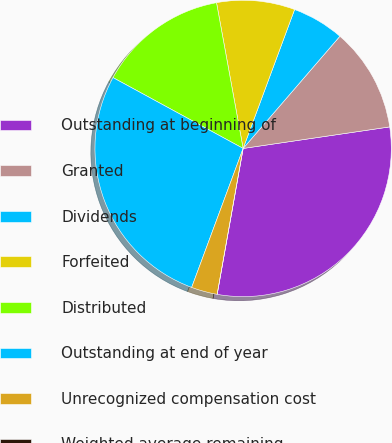Convert chart to OTSL. <chart><loc_0><loc_0><loc_500><loc_500><pie_chart><fcel>Outstanding at beginning of<fcel>Granted<fcel>Dividends<fcel>Forfeited<fcel>Distributed<fcel>Outstanding at end of year<fcel>Unrecognized compensation cost<fcel>Weighted average remaining<nl><fcel>30.13%<fcel>11.35%<fcel>5.68%<fcel>8.52%<fcel>14.19%<fcel>27.29%<fcel>2.84%<fcel>0.0%<nl></chart> 